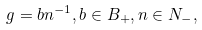<formula> <loc_0><loc_0><loc_500><loc_500>g = b n ^ { - 1 } , b \in B _ { + } , n \in N _ { - } ,</formula> 